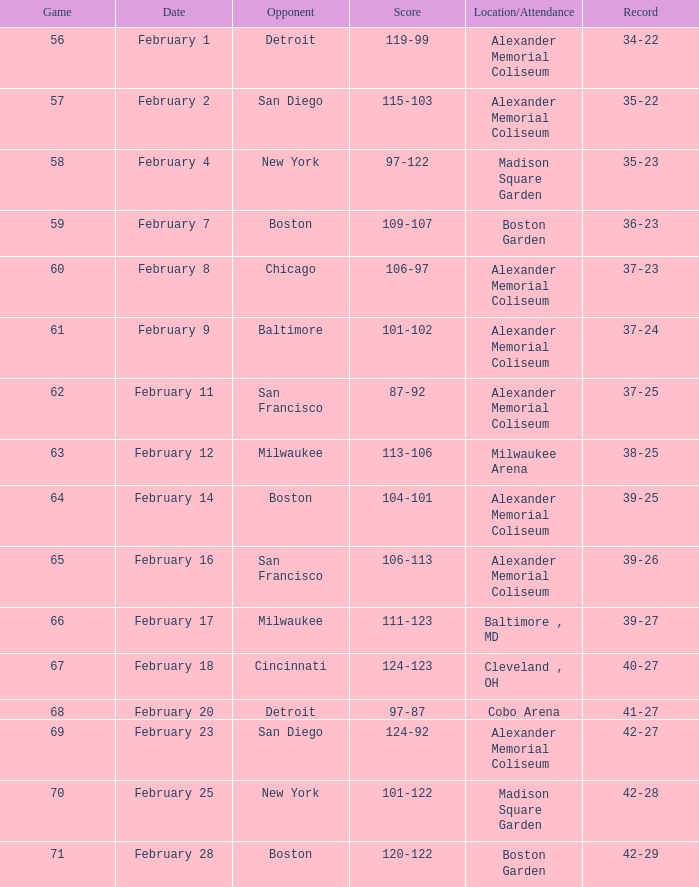What is the game # with an outcome of 87-92? 62.0. 